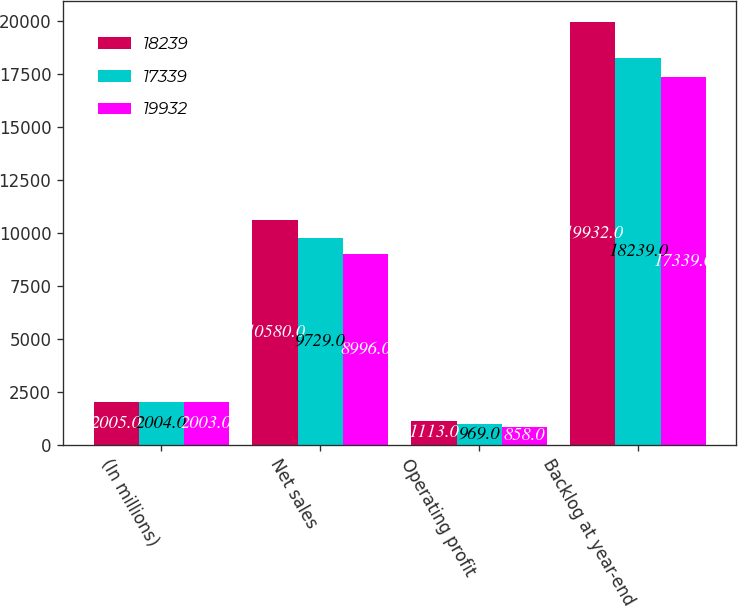Convert chart to OTSL. <chart><loc_0><loc_0><loc_500><loc_500><stacked_bar_chart><ecel><fcel>(In millions)<fcel>Net sales<fcel>Operating profit<fcel>Backlog at year-end<nl><fcel>18239<fcel>2005<fcel>10580<fcel>1113<fcel>19932<nl><fcel>17339<fcel>2004<fcel>9729<fcel>969<fcel>18239<nl><fcel>19932<fcel>2003<fcel>8996<fcel>858<fcel>17339<nl></chart> 